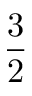<formula> <loc_0><loc_0><loc_500><loc_500>\frac { 3 } { 2 }</formula> 